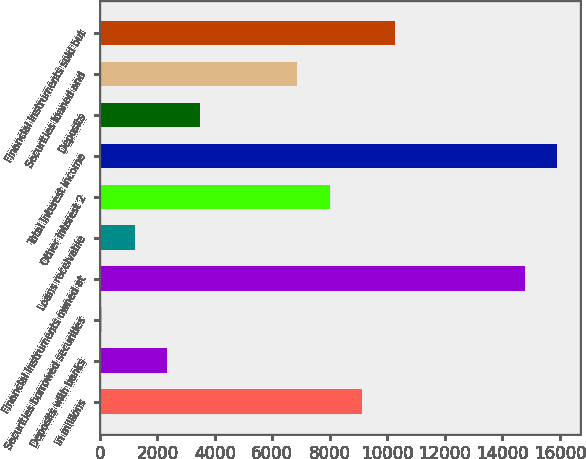Convert chart. <chart><loc_0><loc_0><loc_500><loc_500><bar_chart><fcel>in millions<fcel>Deposits with banks<fcel>Securities borrowed securities<fcel>Financial instruments owned at<fcel>Loans receivable<fcel>Other interest 2<fcel>Total interest income<fcel>Deposits<fcel>Securities loaned and<fcel>Financial instruments sold but<nl><fcel>9120.2<fcel>2337.8<fcel>77<fcel>14772.2<fcel>1207.4<fcel>7989.8<fcel>15902.6<fcel>3468.2<fcel>6859.4<fcel>10250.6<nl></chart> 